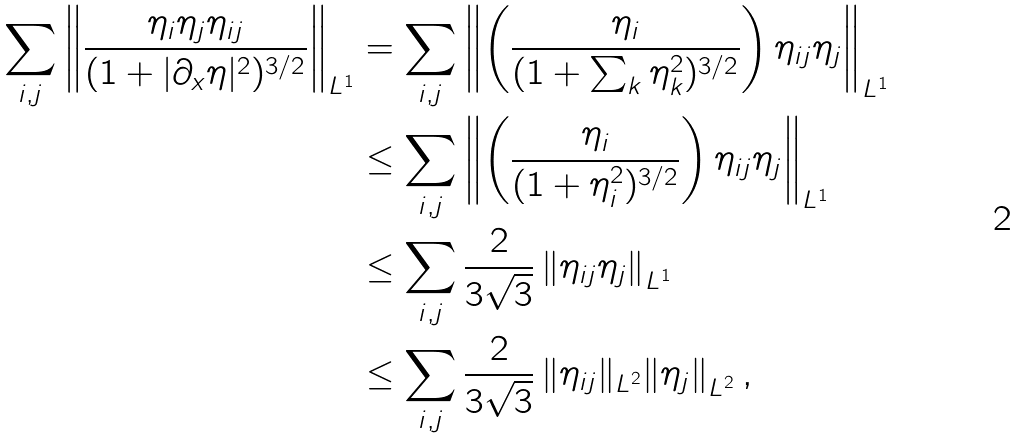<formula> <loc_0><loc_0><loc_500><loc_500>\sum _ { i , j } \left \| \frac { \eta _ { i } \eta _ { j } \eta _ { i j } } { ( 1 + | \partial _ { x } \eta | ^ { 2 } ) ^ { 3 / 2 } } \right \| _ { L ^ { 1 } } & = \sum _ { i , j } \left \| \left ( \frac { \eta _ { i } } { ( 1 + \sum _ { k } \eta _ { k } ^ { 2 } ) ^ { 3 / 2 } } \right ) \eta _ { i j } \eta _ { j } \right \| _ { L ^ { 1 } } \\ & \leq \sum _ { i , j } \left \| \left ( \frac { \eta _ { i } } { ( 1 + \eta _ { i } ^ { 2 } ) ^ { 3 / 2 } } \right ) \eta _ { i j } \eta _ { j } \right \| _ { L ^ { 1 } } \\ & \leq \sum _ { i , j } \frac { 2 } { 3 \sqrt { 3 } } \left \| \eta _ { i j } \eta _ { j } \right \| _ { L ^ { 1 } } \\ & \leq \sum _ { i , j } \frac { 2 } { 3 \sqrt { 3 } } \left \| \eta _ { i j } \| _ { L ^ { 2 } } \| \eta _ { j } \right \| _ { L ^ { 2 } } ,</formula> 